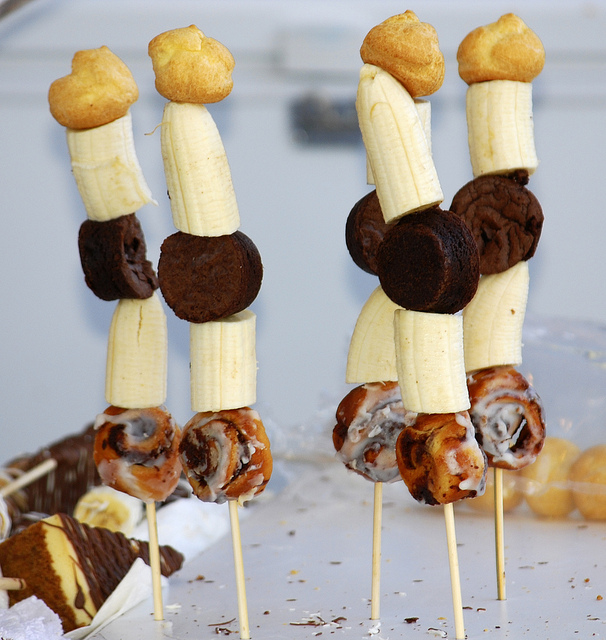<image>What fruit is on the stick? I am not sure. It could be bananas, or there might be no fruit on the stick. How was this made? It is unknown how this was made. It could have been made by hand or by putting it on a stick. What fruit is on the stick? It can be seen that there are bananas on the stick. How was this made? I don't know how this was made. It could be made by putting it on a stick or by using toothpicks. 